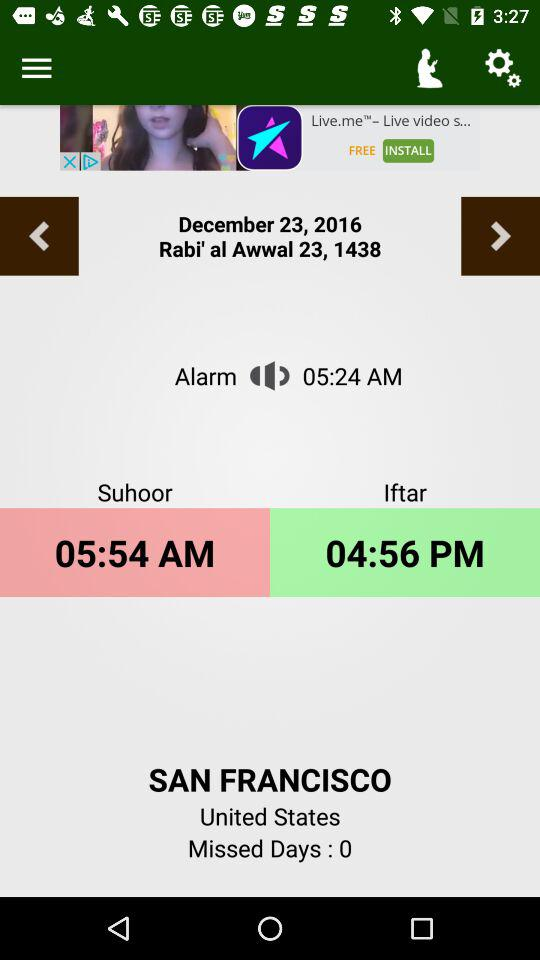How many days have I missed?
Answer the question using a single word or phrase. 0 